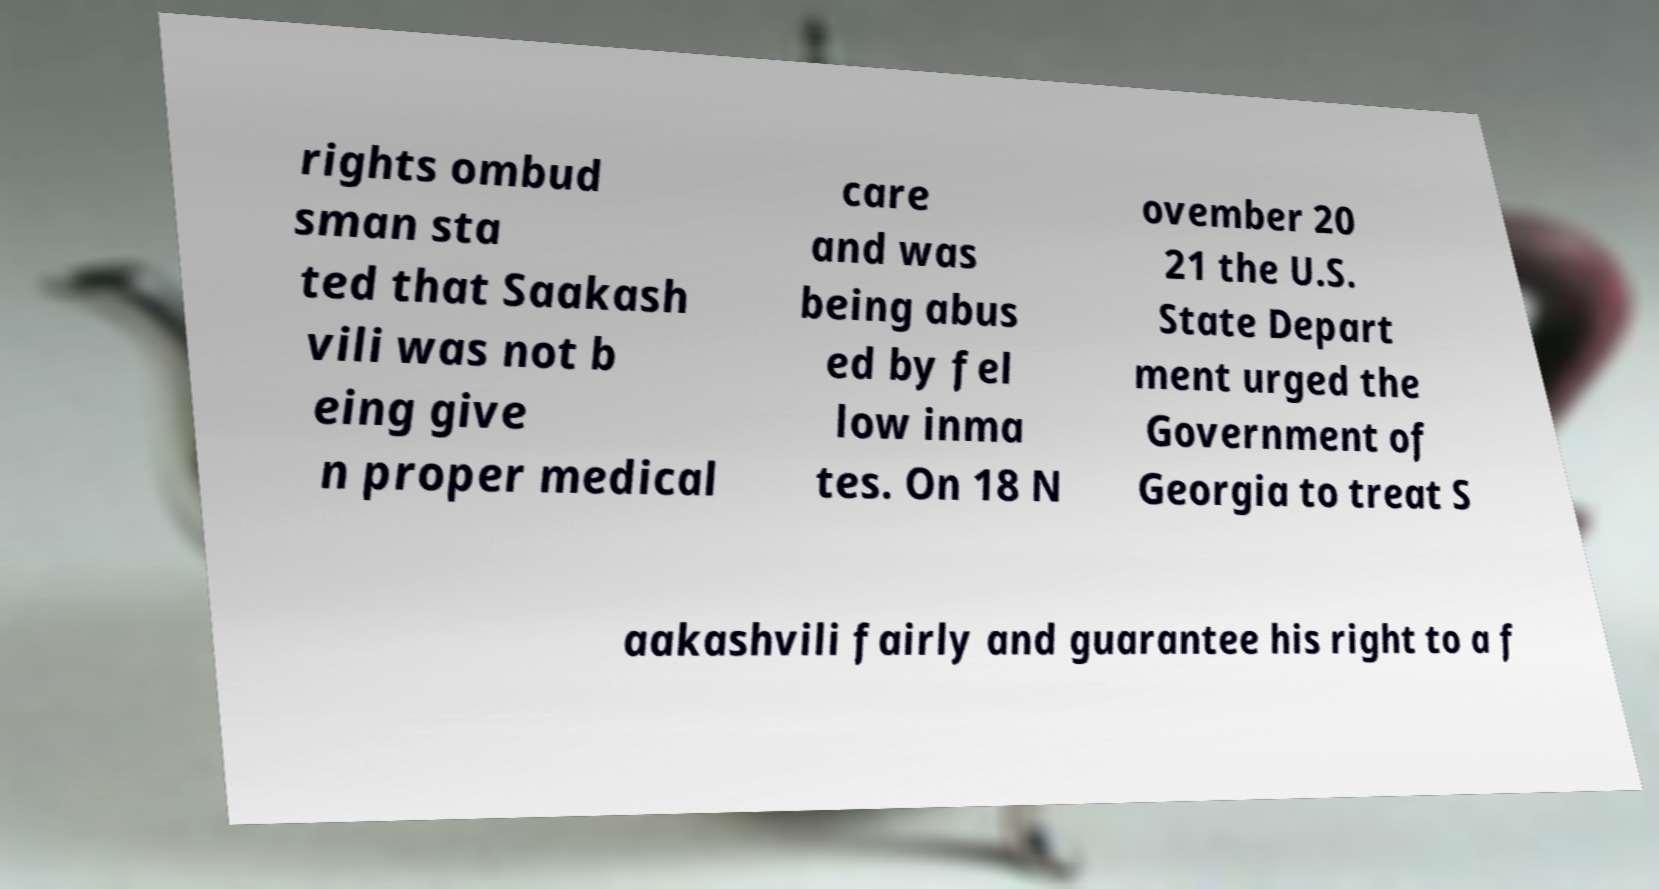Could you extract and type out the text from this image? rights ombud sman sta ted that Saakash vili was not b eing give n proper medical care and was being abus ed by fel low inma tes. On 18 N ovember 20 21 the U.S. State Depart ment urged the Government of Georgia to treat S aakashvili fairly and guarantee his right to a f 